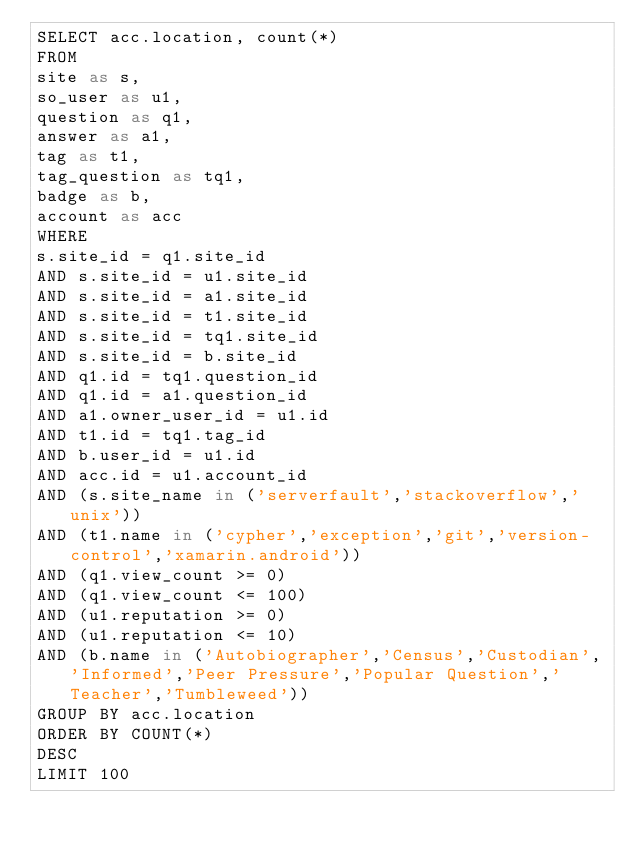<code> <loc_0><loc_0><loc_500><loc_500><_SQL_>SELECT acc.location, count(*)
FROM
site as s,
so_user as u1,
question as q1,
answer as a1,
tag as t1,
tag_question as tq1,
badge as b,
account as acc
WHERE
s.site_id = q1.site_id
AND s.site_id = u1.site_id
AND s.site_id = a1.site_id
AND s.site_id = t1.site_id
AND s.site_id = tq1.site_id
AND s.site_id = b.site_id
AND q1.id = tq1.question_id
AND q1.id = a1.question_id
AND a1.owner_user_id = u1.id
AND t1.id = tq1.tag_id
AND b.user_id = u1.id
AND acc.id = u1.account_id
AND (s.site_name in ('serverfault','stackoverflow','unix'))
AND (t1.name in ('cypher','exception','git','version-control','xamarin.android'))
AND (q1.view_count >= 0)
AND (q1.view_count <= 100)
AND (u1.reputation >= 0)
AND (u1.reputation <= 10)
AND (b.name in ('Autobiographer','Census','Custodian','Informed','Peer Pressure','Popular Question','Teacher','Tumbleweed'))
GROUP BY acc.location
ORDER BY COUNT(*)
DESC
LIMIT 100
</code> 